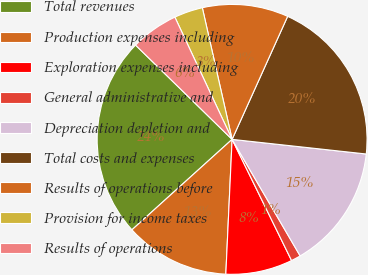<chart> <loc_0><loc_0><loc_500><loc_500><pie_chart><fcel>Total revenues<fcel>Production expenses including<fcel>Exploration expenses including<fcel>General administrative and<fcel>Depreciation depletion and<fcel>Total costs and expenses<fcel>Results of operations before<fcel>Provision for income taxes<fcel>Results of operations<nl><fcel>24.0%<fcel>12.57%<fcel>8.0%<fcel>1.15%<fcel>14.86%<fcel>19.98%<fcel>10.29%<fcel>3.43%<fcel>5.72%<nl></chart> 